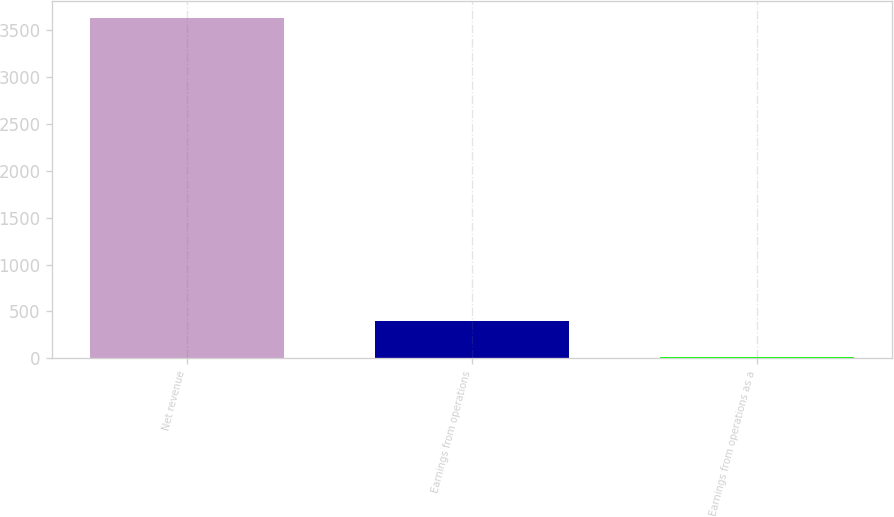Convert chart to OTSL. <chart><loc_0><loc_0><loc_500><loc_500><bar_chart><fcel>Net revenue<fcel>Earnings from operations<fcel>Earnings from operations as a<nl><fcel>3629<fcel>399<fcel>11<nl></chart> 